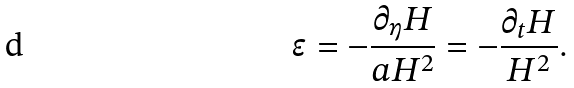<formula> <loc_0><loc_0><loc_500><loc_500>\epsilon = - \frac { \partial _ { \eta } H } { a H ^ { 2 } } = - \frac { \partial _ { t } H } { H ^ { 2 } } .</formula> 